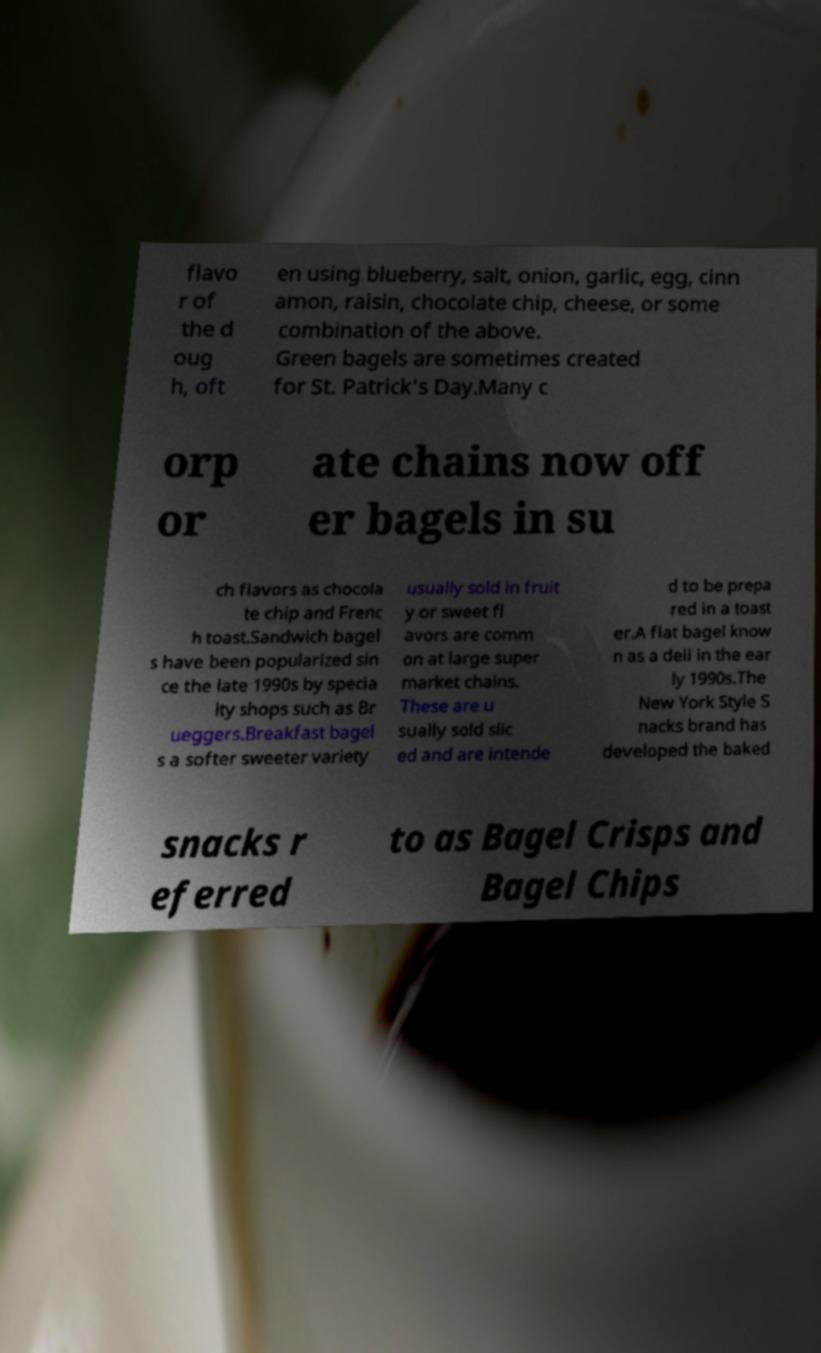I need the written content from this picture converted into text. Can you do that? flavo r of the d oug h, oft en using blueberry, salt, onion, garlic, egg, cinn amon, raisin, chocolate chip, cheese, or some combination of the above. Green bagels are sometimes created for St. Patrick's Day.Many c orp or ate chains now off er bagels in su ch flavors as chocola te chip and Frenc h toast.Sandwich bagel s have been popularized sin ce the late 1990s by specia lty shops such as Br ueggers.Breakfast bagel s a softer sweeter variety usually sold in fruit y or sweet fl avors are comm on at large super market chains. These are u sually sold slic ed and are intende d to be prepa red in a toast er.A flat bagel know n as a deli in the ear ly 1990s.The New York Style S nacks brand has developed the baked snacks r eferred to as Bagel Crisps and Bagel Chips 